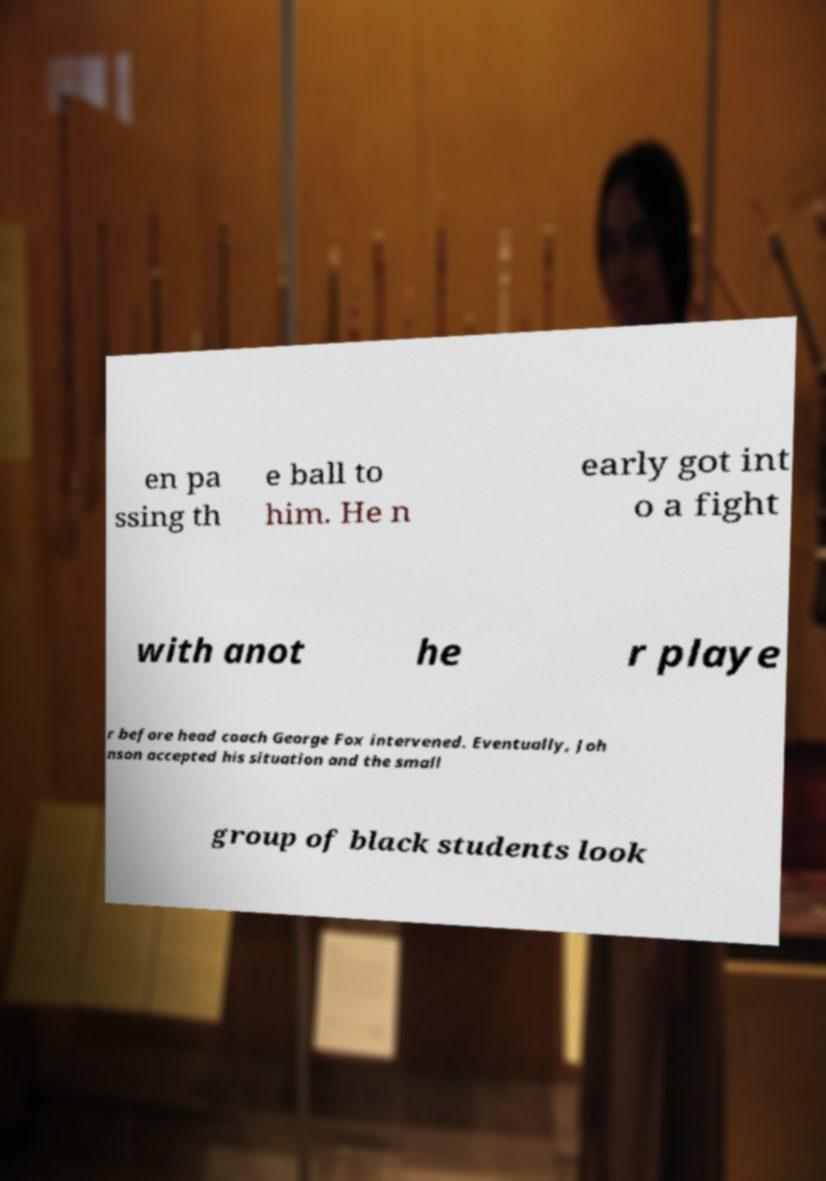I need the written content from this picture converted into text. Can you do that? en pa ssing th e ball to him. He n early got int o a fight with anot he r playe r before head coach George Fox intervened. Eventually, Joh nson accepted his situation and the small group of black students look 